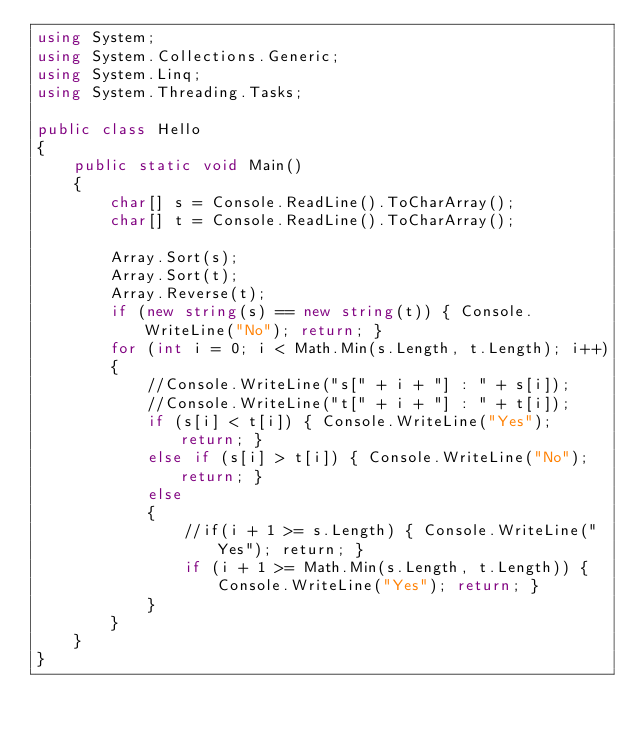<code> <loc_0><loc_0><loc_500><loc_500><_C#_>using System;
using System.Collections.Generic;
using System.Linq;
using System.Threading.Tasks;

public class Hello
{
    public static void Main()
    {
        char[] s = Console.ReadLine().ToCharArray();
        char[] t = Console.ReadLine().ToCharArray();

        Array.Sort(s);
        Array.Sort(t);
        Array.Reverse(t);
        if (new string(s) == new string(t)) { Console.WriteLine("No"); return; }
        for (int i = 0; i < Math.Min(s.Length, t.Length); i++)
        {
            //Console.WriteLine("s[" + i + "] : " + s[i]);
            //Console.WriteLine("t[" + i + "] : " + t[i]);
            if (s[i] < t[i]) { Console.WriteLine("Yes"); return; }
            else if (s[i] > t[i]) { Console.WriteLine("No"); return; }
            else
            {
                //if(i + 1 >= s.Length) { Console.WriteLine("Yes"); return; }
                if (i + 1 >= Math.Min(s.Length, t.Length)) { Console.WriteLine("Yes"); return; }
            }
        }
    }
}

</code> 